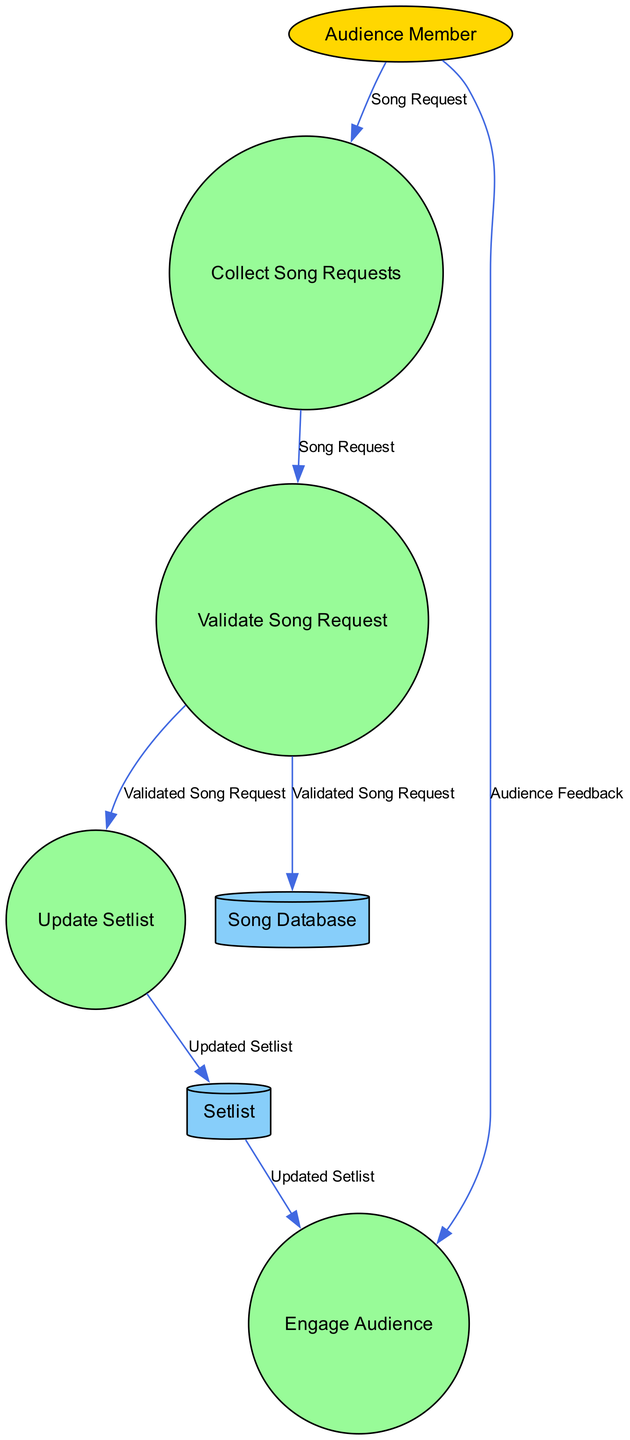What is the first process in the diagram? The first process listed in the diagram is "Collect Song Requests." This can be determined by looking at the processes section and identifying the order in which they are presented.
Answer: Collect Song Requests What does the "Audience Member" contribute to the process flow? The "Audience Member" contributes "Song Request" to the "Collect Song Requests" process and also provides "Audience Feedback" to the "Engage Audience" process. This is evident from the data flows that originate from the external entity.
Answer: Song Request; Audience Feedback How many processes are in the diagram? There are four processes in the diagram: "Collect Song Requests," "Validate Song Request," "Update Setlist," and "Engage Audience." By counting the items listed in the processes section, the total is determined.
Answer: Four Which data store receives the "Updated Setlist" and what is the type of that data store? The "Setlist" data store receives the "Updated Setlist," and it is a cylinder type data store as indicated by its shape in the diagram. The data flows show that "Update Setlist" outputs to "Setlist."
Answer: Setlist; Cylinder What is the output of the "Validate Song Request" process? The outputs of the "Validate Song Request" process are "Validation Result" and it also forwards the "Validated Song Request" to the "Update Setlist" process. This is visible when examining the process and its labeled outputs.
Answer: Validation Result; Validated Song Request How does the "Update Setlist" process interact with the "Setlist"? The "Update Setlist" process outputs "Updated Setlist," which is then stored in the "Setlist" data store. The data flow shows that this process updates the data store with the latest setlist information.
Answer: It updates the Setlist with the Updated Setlist What kind of feedback does the audience provide during the engagement process? The audience provides "Audience Feedback" during the "Engage Audience" process. This detail is directly stated in the data flow leading to the "Engage Audience" process from the "Audience Member."
Answer: Audience Feedback Which process follows after the "Validate Song Request"? After the "Validate Song Request," the next process is "Update Setlist." This is determined by examining the data flow that transitions from "Validate Song Request" to "Update Setlist."
Answer: Update Setlist Which entity is involved in providing song requests? The "Audience Member" is the entity involved in providing song requests, as indicated by the external entity section of the diagram. It is explicitly stated that the audience member can make song requests.
Answer: Audience Member 